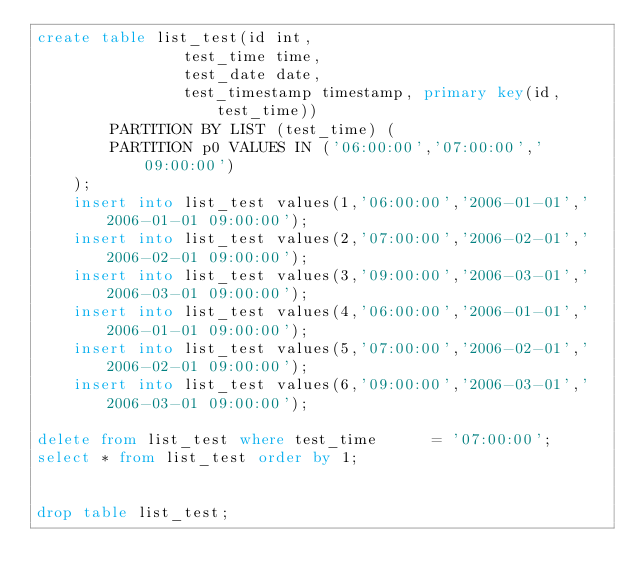Convert code to text. <code><loc_0><loc_0><loc_500><loc_500><_SQL_>create table list_test(id int,	
				test_time time,
				test_date date,
				test_timestamp timestamp, primary key(id,test_time))
		PARTITION BY LIST (test_time) (
		PARTITION p0 VALUES IN ('06:00:00','07:00:00','09:00:00')
	);
	insert into list_test values(1,'06:00:00','2006-01-01','2006-01-01 09:00:00');
	insert into list_test values(2,'07:00:00','2006-02-01','2006-02-01 09:00:00');
	insert into list_test values(3,'09:00:00','2006-03-01','2006-03-01 09:00:00');
	insert into list_test values(4,'06:00:00','2006-01-01','2006-01-01 09:00:00');
	insert into list_test values(5,'07:00:00','2006-02-01','2006-02-01 09:00:00');
	insert into list_test values(6,'09:00:00','2006-03-01','2006-03-01 09:00:00');

delete from list_test where test_time      = '07:00:00';
select * from list_test order by 1;


drop table list_test;
</code> 